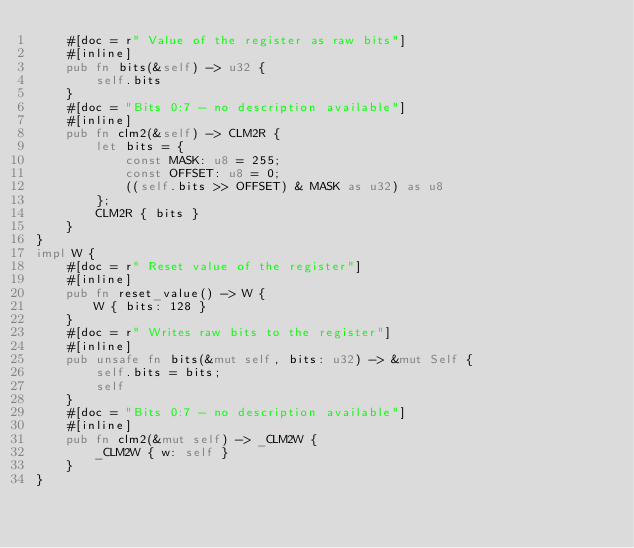<code> <loc_0><loc_0><loc_500><loc_500><_Rust_>    #[doc = r" Value of the register as raw bits"]
    #[inline]
    pub fn bits(&self) -> u32 {
        self.bits
    }
    #[doc = "Bits 0:7 - no description available"]
    #[inline]
    pub fn clm2(&self) -> CLM2R {
        let bits = {
            const MASK: u8 = 255;
            const OFFSET: u8 = 0;
            ((self.bits >> OFFSET) & MASK as u32) as u8
        };
        CLM2R { bits }
    }
}
impl W {
    #[doc = r" Reset value of the register"]
    #[inline]
    pub fn reset_value() -> W {
        W { bits: 128 }
    }
    #[doc = r" Writes raw bits to the register"]
    #[inline]
    pub unsafe fn bits(&mut self, bits: u32) -> &mut Self {
        self.bits = bits;
        self
    }
    #[doc = "Bits 0:7 - no description available"]
    #[inline]
    pub fn clm2(&mut self) -> _CLM2W {
        _CLM2W { w: self }
    }
}
</code> 